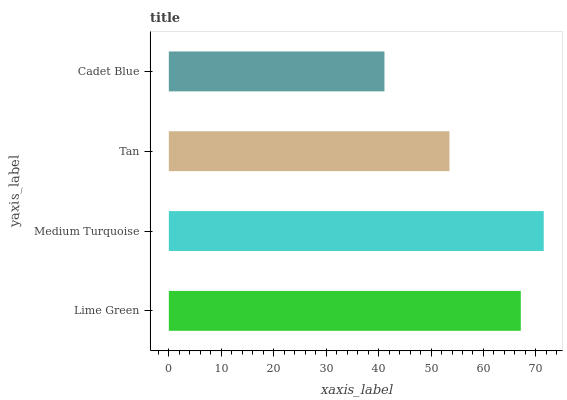Is Cadet Blue the minimum?
Answer yes or no. Yes. Is Medium Turquoise the maximum?
Answer yes or no. Yes. Is Tan the minimum?
Answer yes or no. No. Is Tan the maximum?
Answer yes or no. No. Is Medium Turquoise greater than Tan?
Answer yes or no. Yes. Is Tan less than Medium Turquoise?
Answer yes or no. Yes. Is Tan greater than Medium Turquoise?
Answer yes or no. No. Is Medium Turquoise less than Tan?
Answer yes or no. No. Is Lime Green the high median?
Answer yes or no. Yes. Is Tan the low median?
Answer yes or no. Yes. Is Tan the high median?
Answer yes or no. No. Is Cadet Blue the low median?
Answer yes or no. No. 